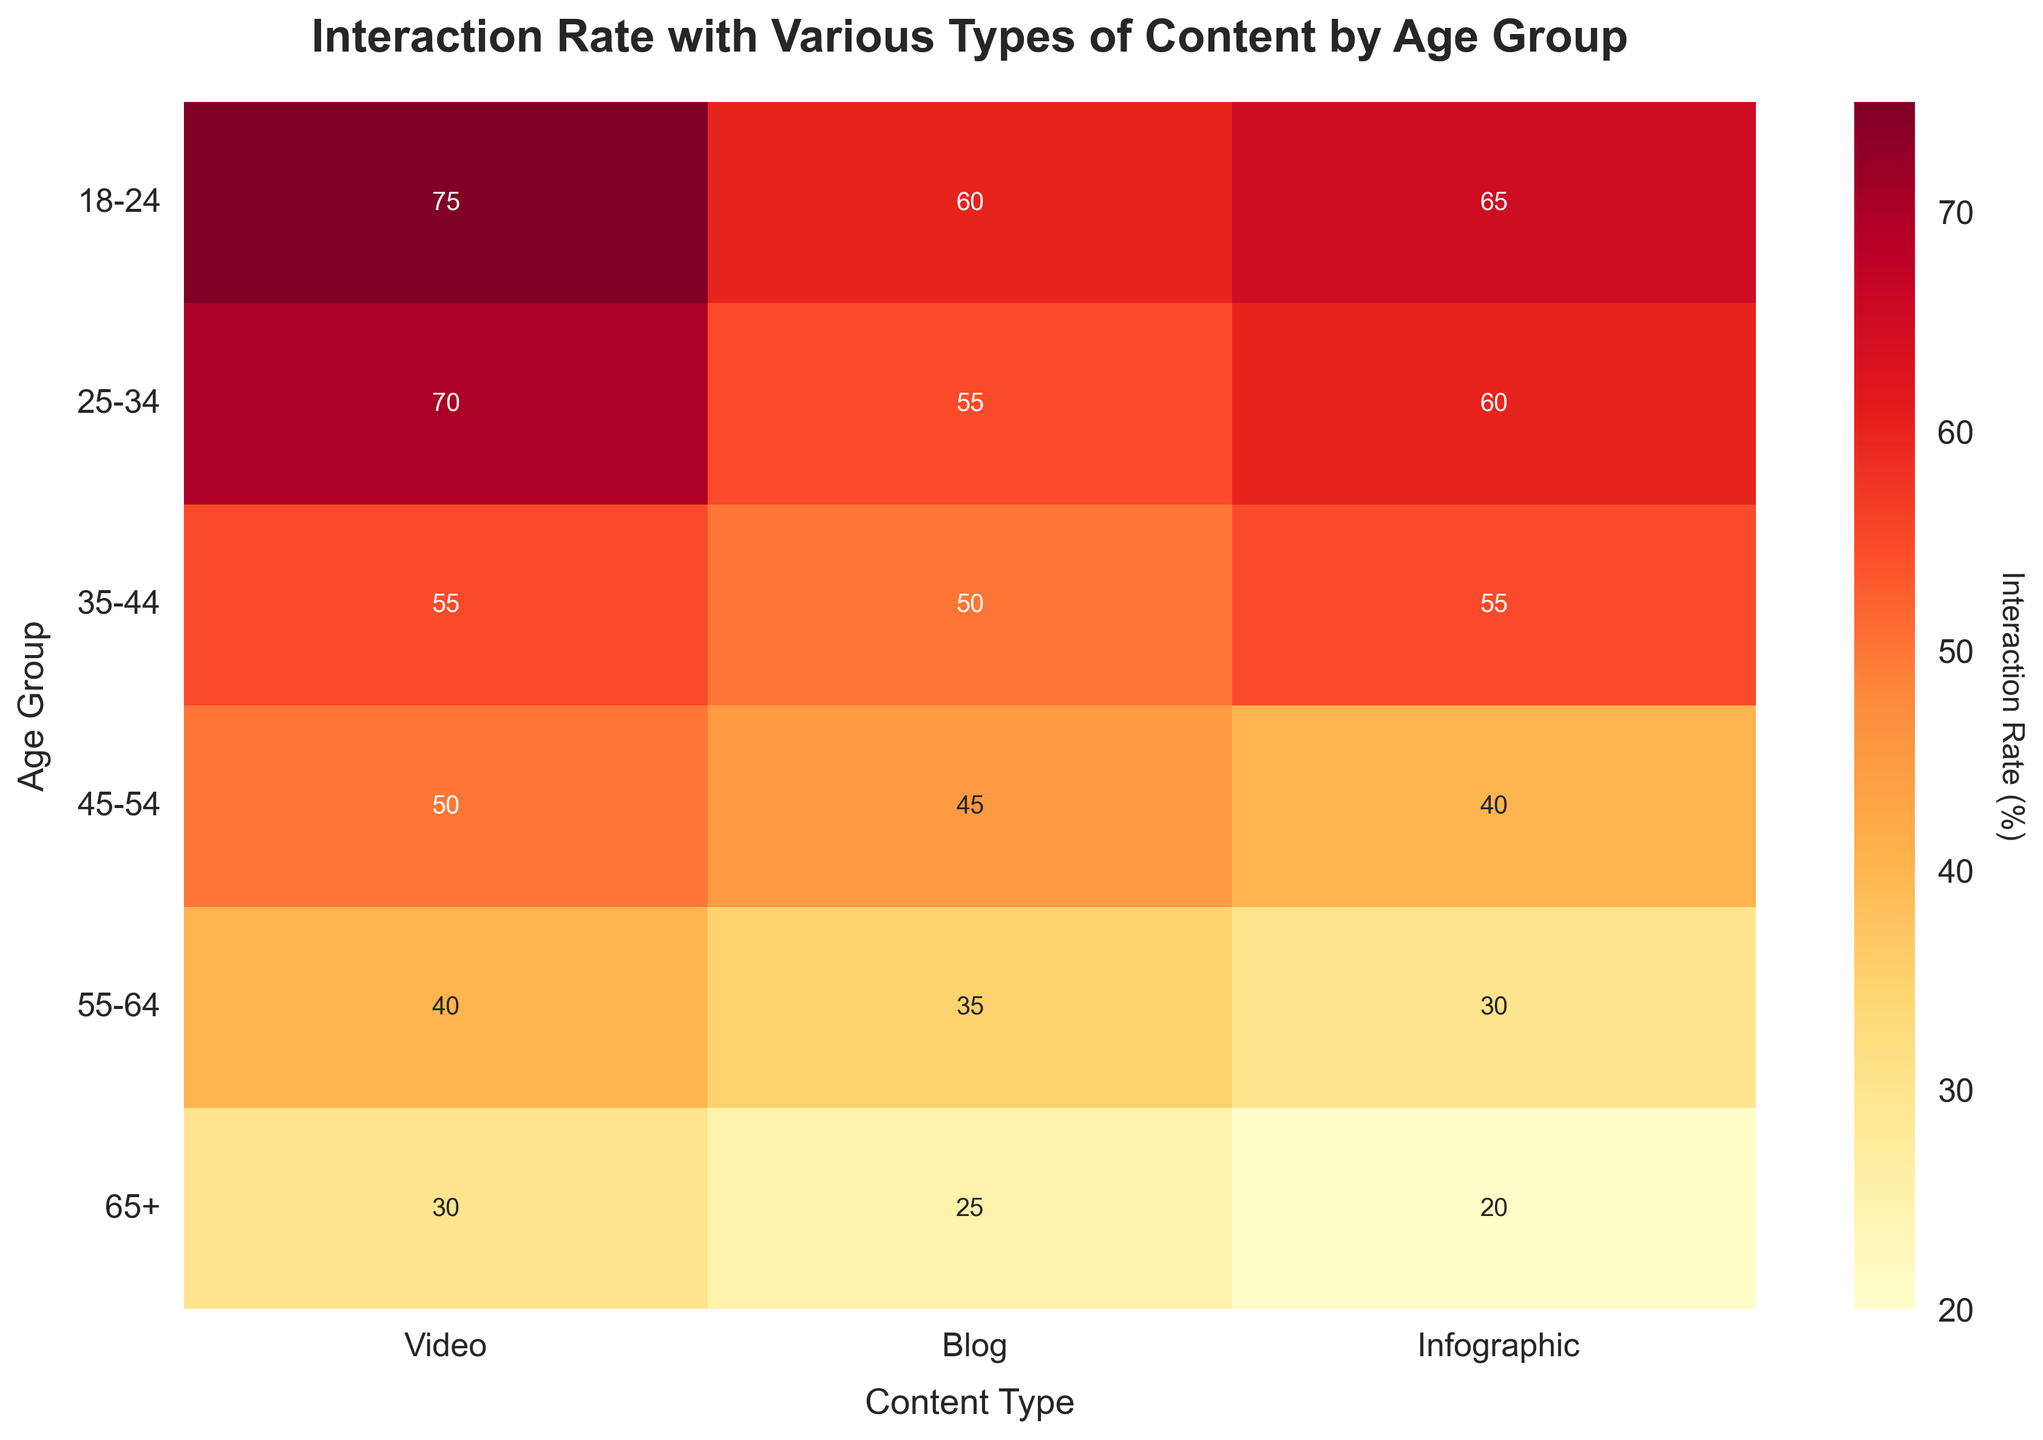What's the title of the heatmap? The title of the heatmap is displayed at the top of the figure. It is: "Interaction Rate with Various Types of Content by Age Group".
Answer: Interaction Rate with Various Types of Content by Age Group What is the interaction rate for Infographics among the 25-34 age group? Locate the row labeled "25-34" and the column labeled "Infographic". The value where they intersect represents the interaction rate, which is 60.
Answer: 60 Which age group has the lowest interaction rate for Blog content? Look at the column labeled "Blog" and find the lowest value. The corresponding row label is the age group, which is "65+", with a value of 25.
Answer: 65+ How does the interaction rate for Video content change as age increases from 18-24 to 65+? Observe the values in the "Video" column from top to bottom. They are 75, 70, 55, 50, 40, and 30. As age increases from 18-24 to 65+, the interaction rate decreases progressively.
Answer: Decreases What's the average interaction rate for the 35-44 age group across all content types? Locate the row labeled "35-44" and find the values for each content type: 55, 50, and 55. Sum these values: 55 + 50 + 55 = 160. Divide by the number of content types (3): 160 / 3 = 53.33.
Answer: 53.33 Is the interaction rate for Blog content higher or lower than Infographic content for the 45-54 age group? Locate the row labeled "45-54" and compare the values in "Blog" (45) and "Infographic" (40). The interaction rate for Blog content is higher.
Answer: Higher Which content type shows the smallest difference in interaction rates between the youngest (18-24) and oldest (65+) age groups? For each content type, calculate the difference between the interaction rates of 18-24 and 65+:
Video: 75 - 30 = 45
Blog: 60 - 25 = 35
Infographic: 65 - 20 = 45
The smallest difference is observed in "Blog", which is 35.
Answer: Blog Rank the content types for the 55-64 age group in terms of interaction rates from highest to lowest. Identify the values in the row labeled "55-64": Video (40), Blog (35), and Infographic (30). The ranking from highest to lowest is: 
1. Video
2. Blog
3. Infographic
Answer: Video, Blog, Infographic What is the total interaction rate for all content types combined in the 45-54 age group? Locate the row labeled "45-54" and sum the values for each content type: 50 + 45 + 40. The total interaction rate is 135.
Answer: 135 Do older age groups generally have lower interaction rates across all types of content compared to younger age groups? Compare the interaction rates across all types of content for each age group, from youngest to oldest. Note that the interaction rates tend to decrease as age increases, indicating a general trend of lower interaction rates among older age groups.
Answer: Yes 